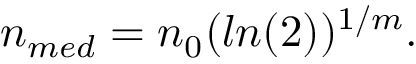Convert formula to latex. <formula><loc_0><loc_0><loc_500><loc_500>\begin{array} { r } { n _ { m e d } = n _ { 0 } ( \ln ( 2 ) ) ^ { 1 / m } . } \end{array}</formula> 